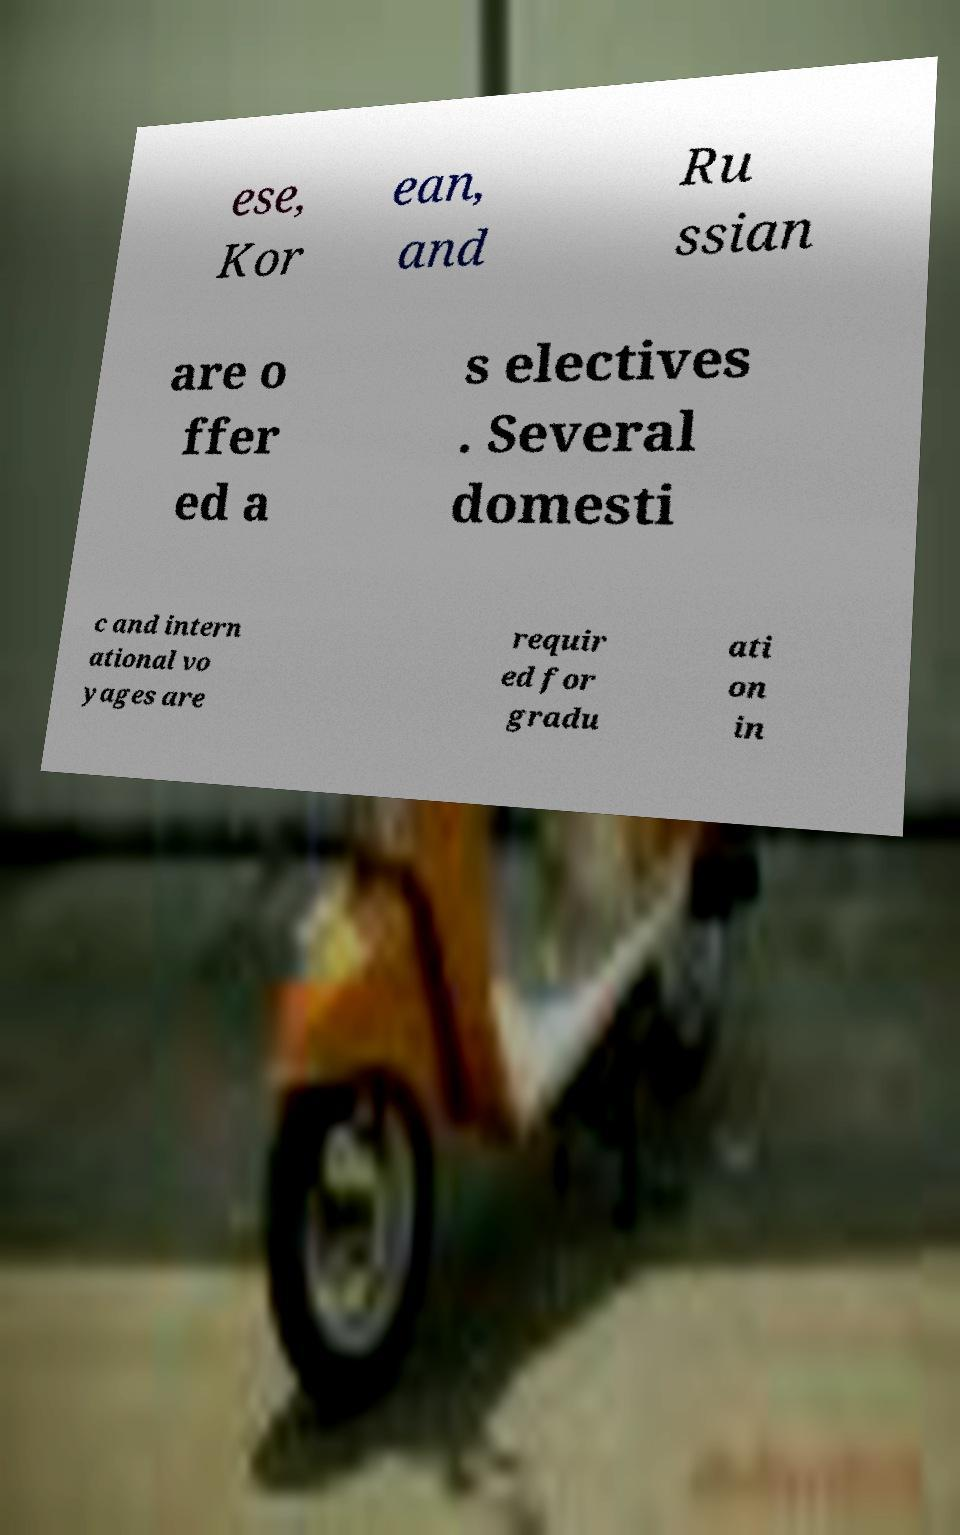Please identify and transcribe the text found in this image. ese, Kor ean, and Ru ssian are o ffer ed a s electives . Several domesti c and intern ational vo yages are requir ed for gradu ati on in 